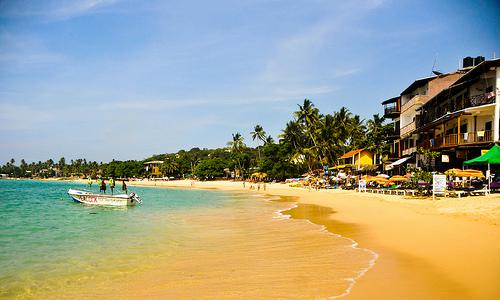Question: what kind of trees are near the buildings?
Choices:
A. Birch trees.
B. Pine trees.
C. Maple.
D. Palm trees.
Answer with the letter. Answer: D Question: how many boats are in the water?
Choices:
A. Three.
B. Four.
C. One.
D. Six.
Answer with the letter. Answer: C 